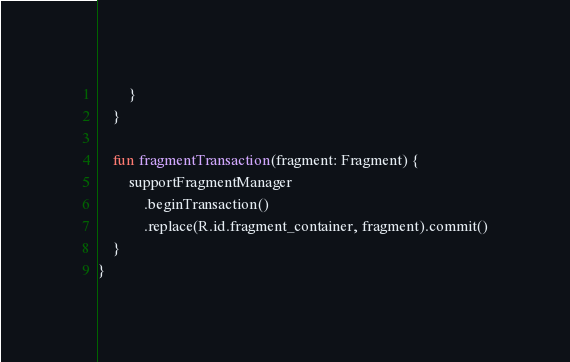Convert code to text. <code><loc_0><loc_0><loc_500><loc_500><_Kotlin_>        }
    }

    fun fragmentTransaction(fragment: Fragment) {
        supportFragmentManager
            .beginTransaction()
            .replace(R.id.fragment_container, fragment).commit()
    }
}</code> 